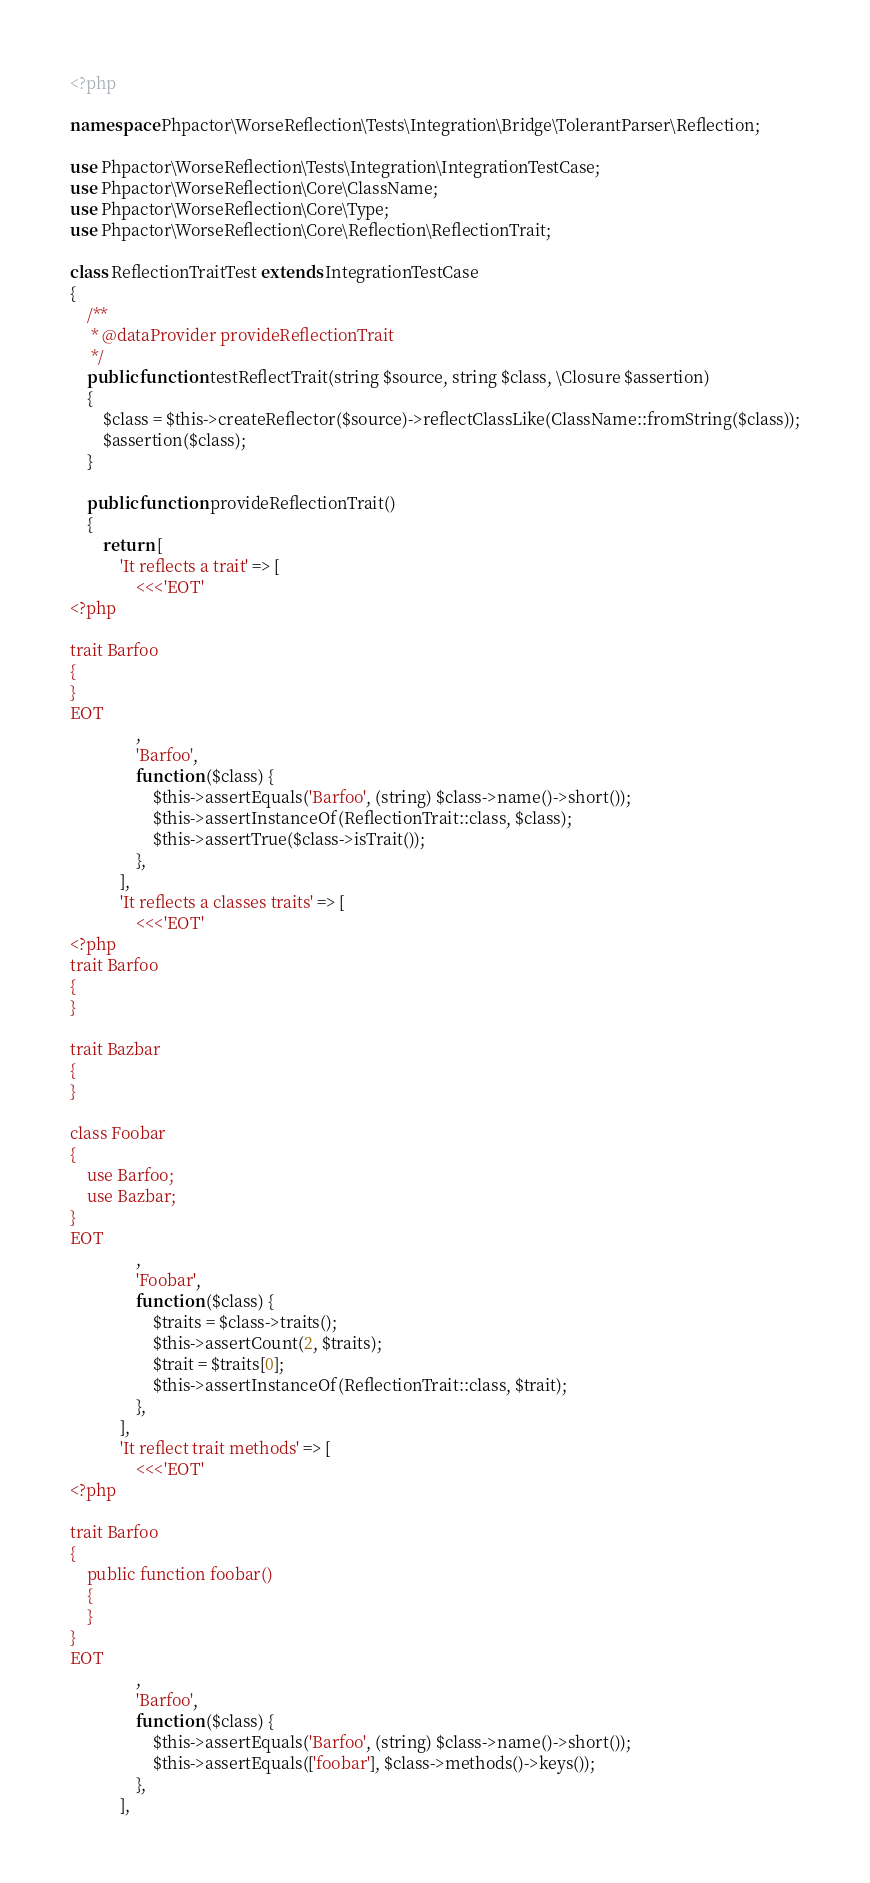Convert code to text. <code><loc_0><loc_0><loc_500><loc_500><_PHP_><?php

namespace Phpactor\WorseReflection\Tests\Integration\Bridge\TolerantParser\Reflection;

use Phpactor\WorseReflection\Tests\Integration\IntegrationTestCase;
use Phpactor\WorseReflection\Core\ClassName;
use Phpactor\WorseReflection\Core\Type;
use Phpactor\WorseReflection\Core\Reflection\ReflectionTrait;

class ReflectionTraitTest extends IntegrationTestCase
{
    /**
     * @dataProvider provideReflectionTrait
     */
    public function testReflectTrait(string $source, string $class, \Closure $assertion)
    {
        $class = $this->createReflector($source)->reflectClassLike(ClassName::fromString($class));
        $assertion($class);
    }

    public function provideReflectionTrait()
    {
        return [
            'It reflects a trait' => [
                <<<'EOT'
<?php

trait Barfoo
{
}
EOT
                ,
                'Barfoo',
                function ($class) {
                    $this->assertEquals('Barfoo', (string) $class->name()->short());
                    $this->assertInstanceOf(ReflectionTrait::class, $class);
                    $this->assertTrue($class->isTrait());
                },
            ],
            'It reflects a classes traits' => [
                <<<'EOT'
<?php
trait Barfoo
{
}

trait Bazbar
{
}

class Foobar
{
    use Barfoo;
    use Bazbar;
}
EOT
                ,
                'Foobar',
                function ($class) {
                    $traits = $class->traits();
                    $this->assertCount(2, $traits);
                    $trait = $traits[0];
                    $this->assertInstanceOf(ReflectionTrait::class, $trait);
                },
            ],
            'It reflect trait methods' => [
                <<<'EOT'
<?php

trait Barfoo
{
    public function foobar()
    {
    }
}
EOT
                ,
                'Barfoo',
                function ($class) {
                    $this->assertEquals('Barfoo', (string) $class->name()->short());
                    $this->assertEquals(['foobar'], $class->methods()->keys());
                },
            ],</code> 